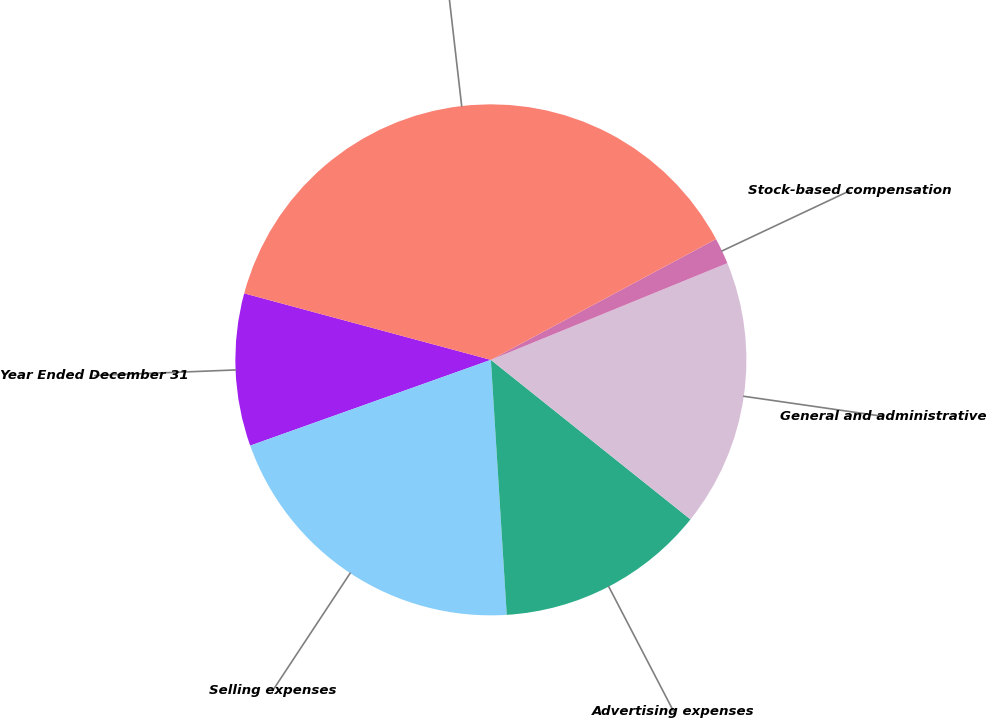<chart> <loc_0><loc_0><loc_500><loc_500><pie_chart><fcel>Year Ended December 31<fcel>Selling expenses<fcel>Advertising expenses<fcel>General and administrative<fcel>Stock-based compensation<fcel>Selling general and<nl><fcel>9.64%<fcel>20.54%<fcel>13.28%<fcel>16.91%<fcel>1.66%<fcel>37.97%<nl></chart> 